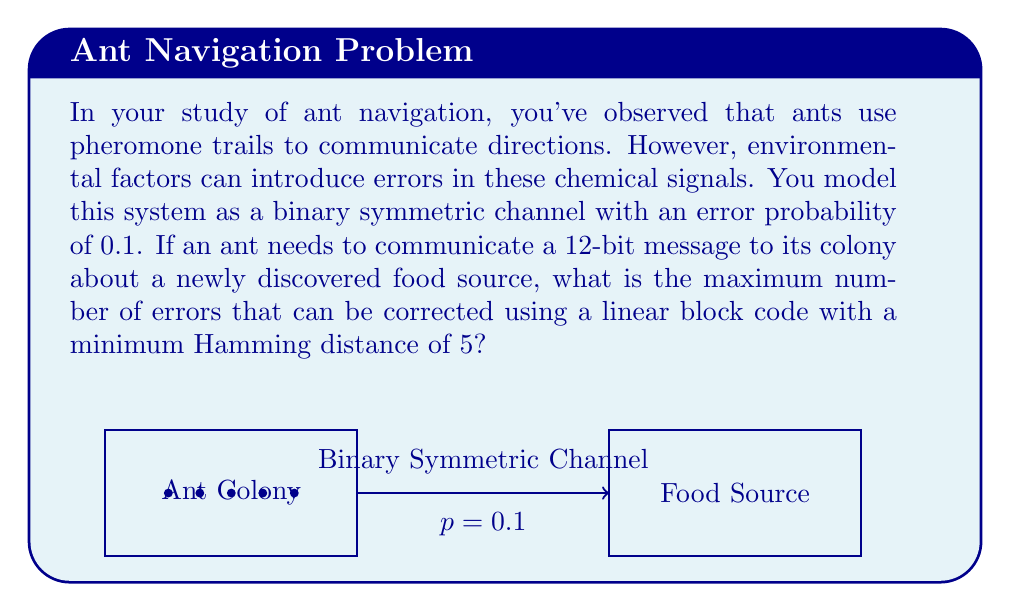Help me with this question. Let's approach this step-by-step:

1) In a linear block code, the number of errors that can be corrected is related to the minimum Hamming distance ($d_{min}$) of the code. The relationship is given by:

   $$t = \left\lfloor\frac{d_{min} - 1}{2}\right\rfloor$$

   where $t$ is the number of errors that can be corrected, and $\lfloor \cdot \rfloor$ denotes the floor function.

2) We are given that $d_{min} = 5$. Let's substitute this into our equation:

   $$t = \left\lfloor\frac{5 - 1}{2}\right\rfloor = \left\lfloor\frac{4}{2}\right\rfloor = \left\lfloor 2 \right\rfloor = 2$$

3) Therefore, this code can correct up to 2 errors in the 12-bit message.

4) It's worth noting that while the binary symmetric channel has an error probability of 0.1, this doesn't directly affect the maximum number of errors that can be corrected. The error-correcting capability is a property of the code itself, determined by its minimum Hamming distance.

5) However, the channel error probability does affect the likelihood of successful decoding. With p = 0.1, the probability of 3 or more errors occurring (which would exceed the error-correcting capability) in a 12-bit message is relatively low, making this a suitable code for the ants' communication system.
Answer: 2 errors 